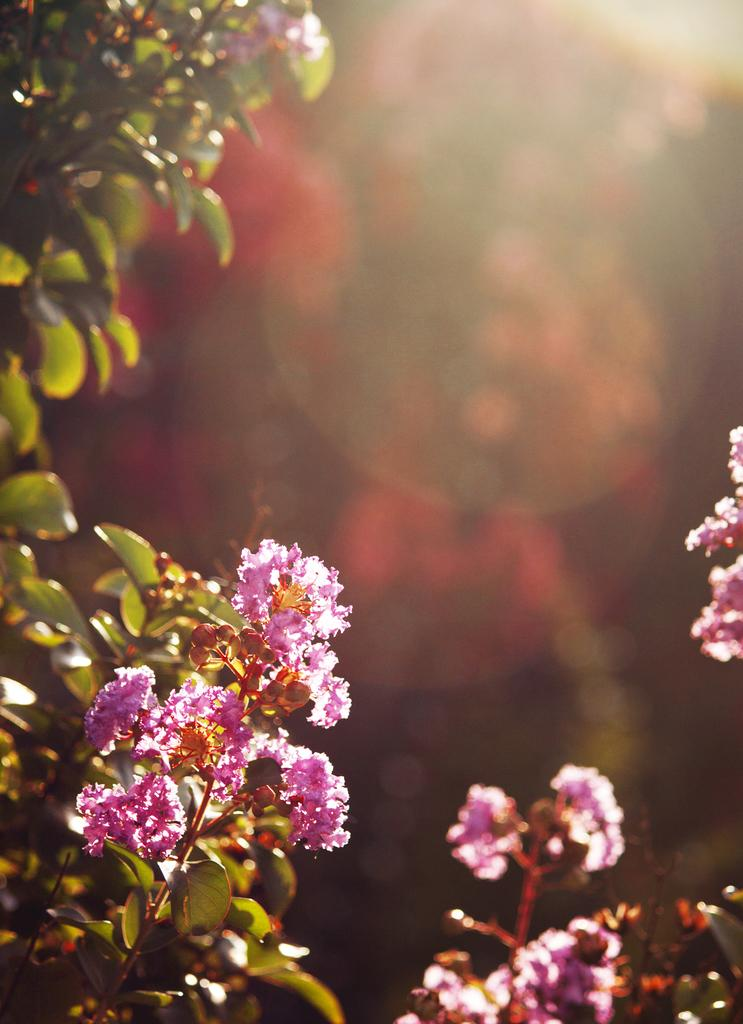What types of living organisms can be seen in the image? Plants and flowers are visible in the image. Can you describe the background of the image? The background of the image is blurred. What type of writing can be seen on the flowers in the image? There is no writing present on the flowers in the image. 